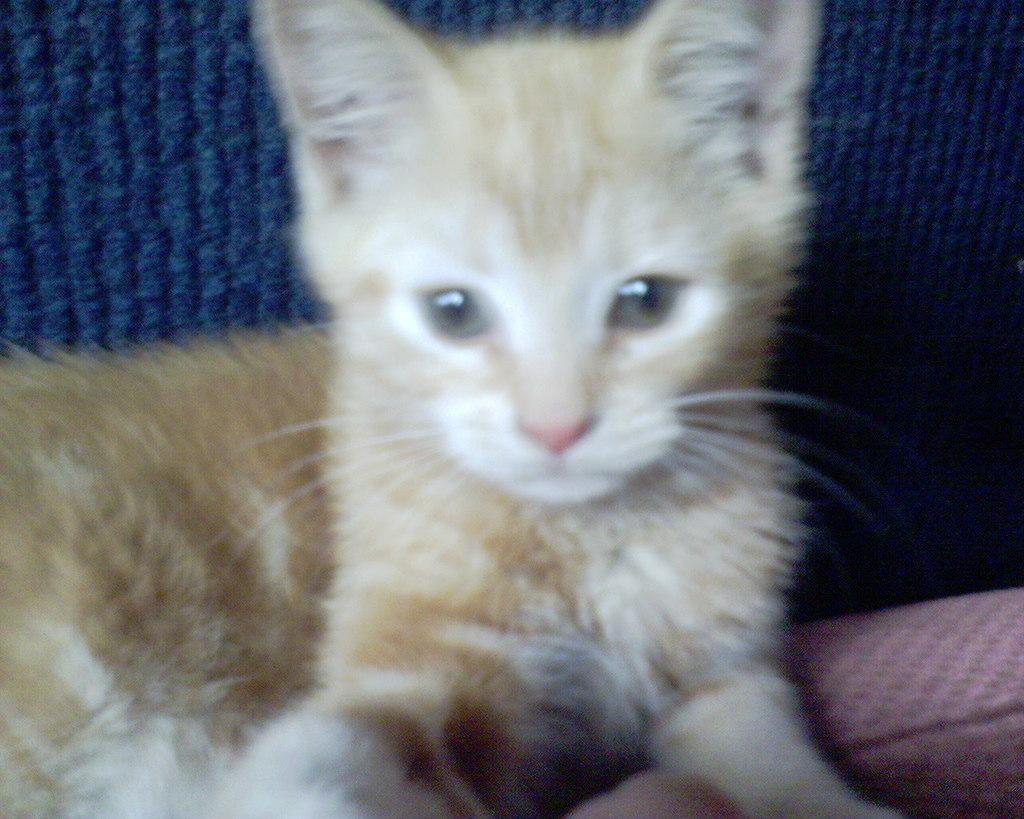What type of animal is in the image? There is a kitten in the image. Where is the kitten located in the image? The kitten is in the middle of the image. What type of card is the kitten holding in the image? There is no card present in the image; it only features a kitten. 